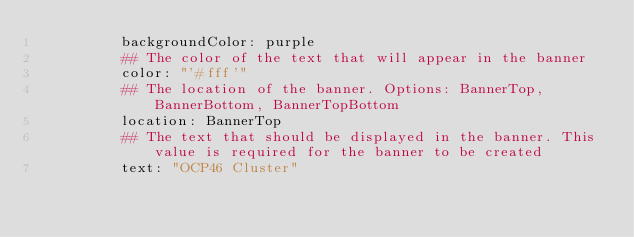<code> <loc_0><loc_0><loc_500><loc_500><_YAML_>          backgroundColor: purple
          ## The color of the text that will appear in the banner
          color: "'#fff'"
          ## The location of the banner. Options: BannerTop, BannerBottom, BannerTopBottom
          location: BannerTop
          ## The text that should be displayed in the banner. This value is required for the banner to be created
          text: "OCP46 Cluster"
</code> 